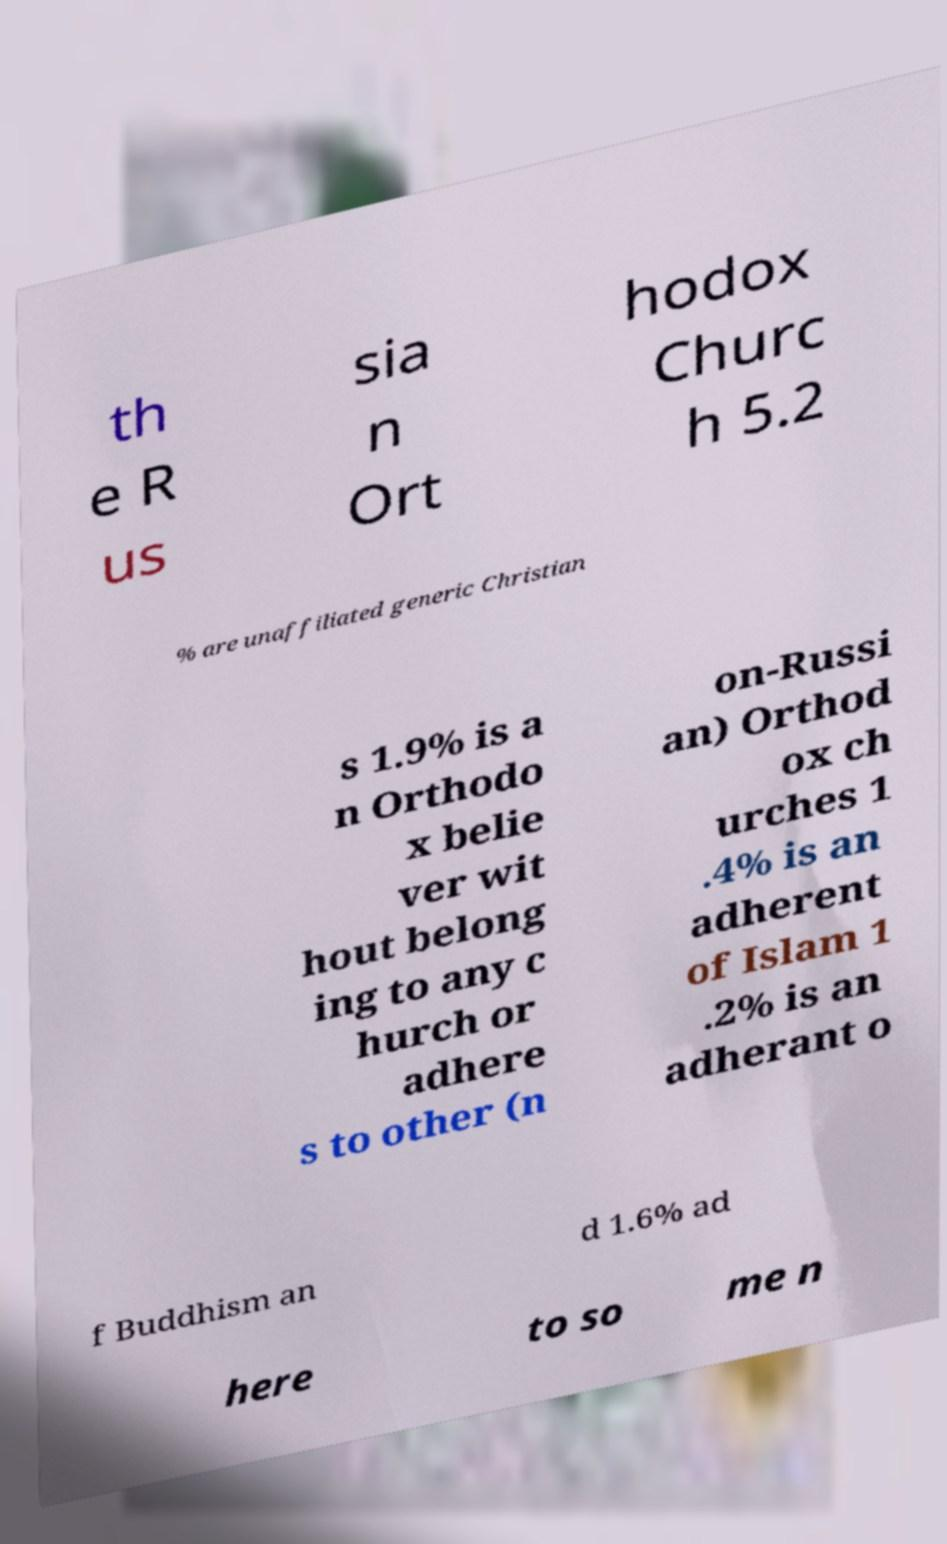For documentation purposes, I need the text within this image transcribed. Could you provide that? th e R us sia n Ort hodox Churc h 5.2 % are unaffiliated generic Christian s 1.9% is a n Orthodo x belie ver wit hout belong ing to any c hurch or adhere s to other (n on-Russi an) Orthod ox ch urches 1 .4% is an adherent of Islam 1 .2% is an adherant o f Buddhism an d 1.6% ad here to so me n 